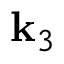<formula> <loc_0><loc_0><loc_500><loc_500>k _ { 3 }</formula> 